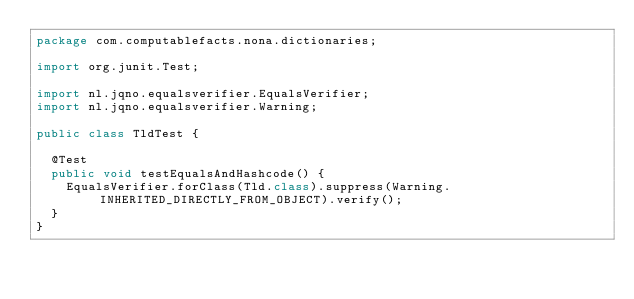Convert code to text. <code><loc_0><loc_0><loc_500><loc_500><_Java_>package com.computablefacts.nona.dictionaries;

import org.junit.Test;

import nl.jqno.equalsverifier.EqualsVerifier;
import nl.jqno.equalsverifier.Warning;

public class TldTest {

  @Test
  public void testEqualsAndHashcode() {
    EqualsVerifier.forClass(Tld.class).suppress(Warning.INHERITED_DIRECTLY_FROM_OBJECT).verify();
  }
}
</code> 